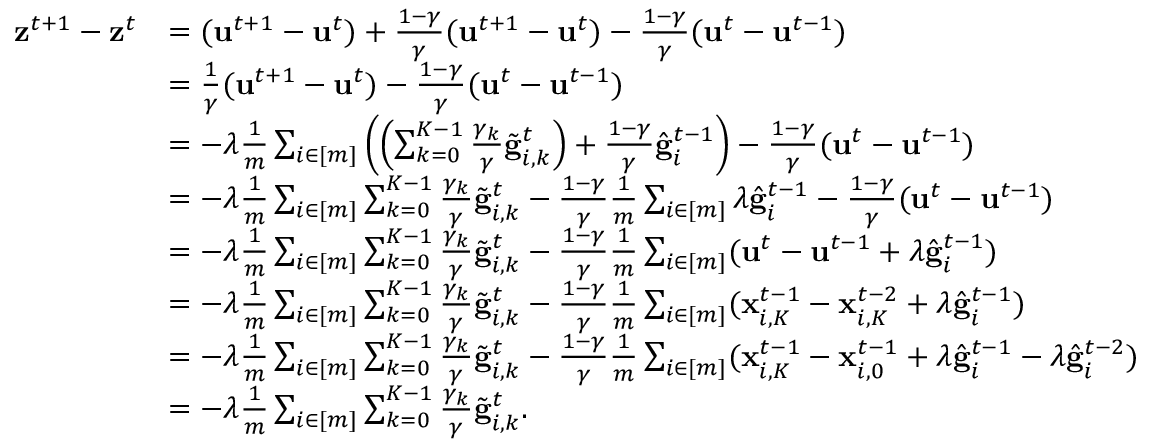Convert formula to latex. <formula><loc_0><loc_0><loc_500><loc_500>\begin{array} { r l } { z ^ { t + 1 } - z ^ { t } } & { = ( u ^ { t + 1 } - u ^ { t } ) + \frac { 1 - \gamma } { \gamma } ( u ^ { t + 1 } - u ^ { t } ) - \frac { 1 - \gamma } { \gamma } ( u ^ { t } - u ^ { t - 1 } ) } \\ & { = \frac { 1 } { \gamma } ( u ^ { t + 1 } - u ^ { t } ) - \frac { 1 - \gamma } { \gamma } ( u ^ { t } - u ^ { t - 1 } ) } \\ & { = - \lambda \frac { 1 } { m } \sum _ { i \in [ m ] } \left ( \left ( \sum _ { k = 0 } ^ { K - 1 } \frac { \gamma _ { k } } { \gamma } \tilde { g } _ { i , k } ^ { t } \right ) + \frac { 1 - \gamma } { \gamma } \hat { g } _ { i } ^ { t - 1 } \right ) - \frac { 1 - \gamma } { \gamma } ( u ^ { t } - u ^ { t - 1 } ) } \\ & { = - \lambda \frac { 1 } { m } \sum _ { i \in [ m ] } \sum _ { k = 0 } ^ { K - 1 } \frac { \gamma _ { k } } { \gamma } \tilde { g } _ { i , k } ^ { t } - \frac { 1 - \gamma } { \gamma } \frac { 1 } { m } \sum _ { i \in [ m ] } \lambda \hat { g } _ { i } ^ { t - 1 } - \frac { 1 - \gamma } { \gamma } ( u ^ { t } - u ^ { t - 1 } ) } \\ & { = - \lambda \frac { 1 } { m } \sum _ { i \in [ m ] } \sum _ { k = 0 } ^ { K - 1 } \frac { \gamma _ { k } } { \gamma } \tilde { g } _ { i , k } ^ { t } - \frac { 1 - \gamma } { \gamma } \frac { 1 } { m } \sum _ { i \in [ m ] } ( u ^ { t } - u ^ { t - 1 } + \lambda \hat { g } _ { i } ^ { t - 1 } ) } \\ & { = - \lambda \frac { 1 } { m } \sum _ { i \in [ m ] } \sum _ { k = 0 } ^ { K - 1 } \frac { \gamma _ { k } } { \gamma } \tilde { g } _ { i , k } ^ { t } - \frac { 1 - \gamma } { \gamma } \frac { 1 } { m } \sum _ { i \in [ m ] } ( x _ { i , K } ^ { t - 1 } - x _ { i , K } ^ { t - 2 } + \lambda \hat { g } _ { i } ^ { t - 1 } ) } \\ & { = - \lambda \frac { 1 } { m } \sum _ { i \in [ m ] } \sum _ { k = 0 } ^ { K - 1 } \frac { \gamma _ { k } } { \gamma } \tilde { g } _ { i , k } ^ { t } - \frac { 1 - \gamma } { \gamma } \frac { 1 } { m } \sum _ { i \in [ m ] } ( x _ { i , K } ^ { t - 1 } - x _ { i , 0 } ^ { t - 1 } + \lambda \hat { g } _ { i } ^ { t - 1 } - \lambda \hat { g } _ { i } ^ { t - 2 } ) } \\ & { = - \lambda \frac { 1 } { m } \sum _ { i \in [ m ] } \sum _ { k = 0 } ^ { K - 1 } \frac { \gamma _ { k } } { \gamma } \tilde { g } _ { i , k } ^ { t } . } \end{array}</formula> 